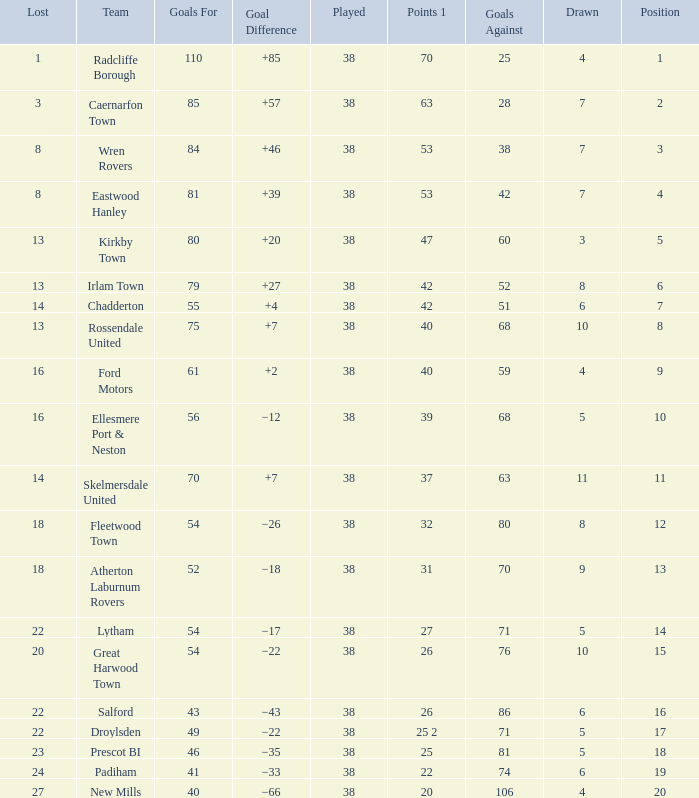How much Drawn has Goals Against of 81, and a Lost larger than 23? 0.0. Would you mind parsing the complete table? {'header': ['Lost', 'Team', 'Goals For', 'Goal Difference', 'Played', 'Points 1', 'Goals Against', 'Drawn', 'Position'], 'rows': [['1', 'Radcliffe Borough', '110', '+85', '38', '70', '25', '4', '1'], ['3', 'Caernarfon Town', '85', '+57', '38', '63', '28', '7', '2'], ['8', 'Wren Rovers', '84', '+46', '38', '53', '38', '7', '3'], ['8', 'Eastwood Hanley', '81', '+39', '38', '53', '42', '7', '4'], ['13', 'Kirkby Town', '80', '+20', '38', '47', '60', '3', '5'], ['13', 'Irlam Town', '79', '+27', '38', '42', '52', '8', '6'], ['14', 'Chadderton', '55', '+4', '38', '42', '51', '6', '7'], ['13', 'Rossendale United', '75', '+7', '38', '40', '68', '10', '8'], ['16', 'Ford Motors', '61', '+2', '38', '40', '59', '4', '9'], ['16', 'Ellesmere Port & Neston', '56', '−12', '38', '39', '68', '5', '10'], ['14', 'Skelmersdale United', '70', '+7', '38', '37', '63', '11', '11'], ['18', 'Fleetwood Town', '54', '−26', '38', '32', '80', '8', '12'], ['18', 'Atherton Laburnum Rovers', '52', '−18', '38', '31', '70', '9', '13'], ['22', 'Lytham', '54', '−17', '38', '27', '71', '5', '14'], ['20', 'Great Harwood Town', '54', '−22', '38', '26', '76', '10', '15'], ['22', 'Salford', '43', '−43', '38', '26', '86', '6', '16'], ['22', 'Droylsden', '49', '−22', '38', '25 2', '71', '5', '17'], ['23', 'Prescot BI', '46', '−35', '38', '25', '81', '5', '18'], ['24', 'Padiham', '41', '−33', '38', '22', '74', '6', '19'], ['27', 'New Mills', '40', '−66', '38', '20', '106', '4', '20']]} 